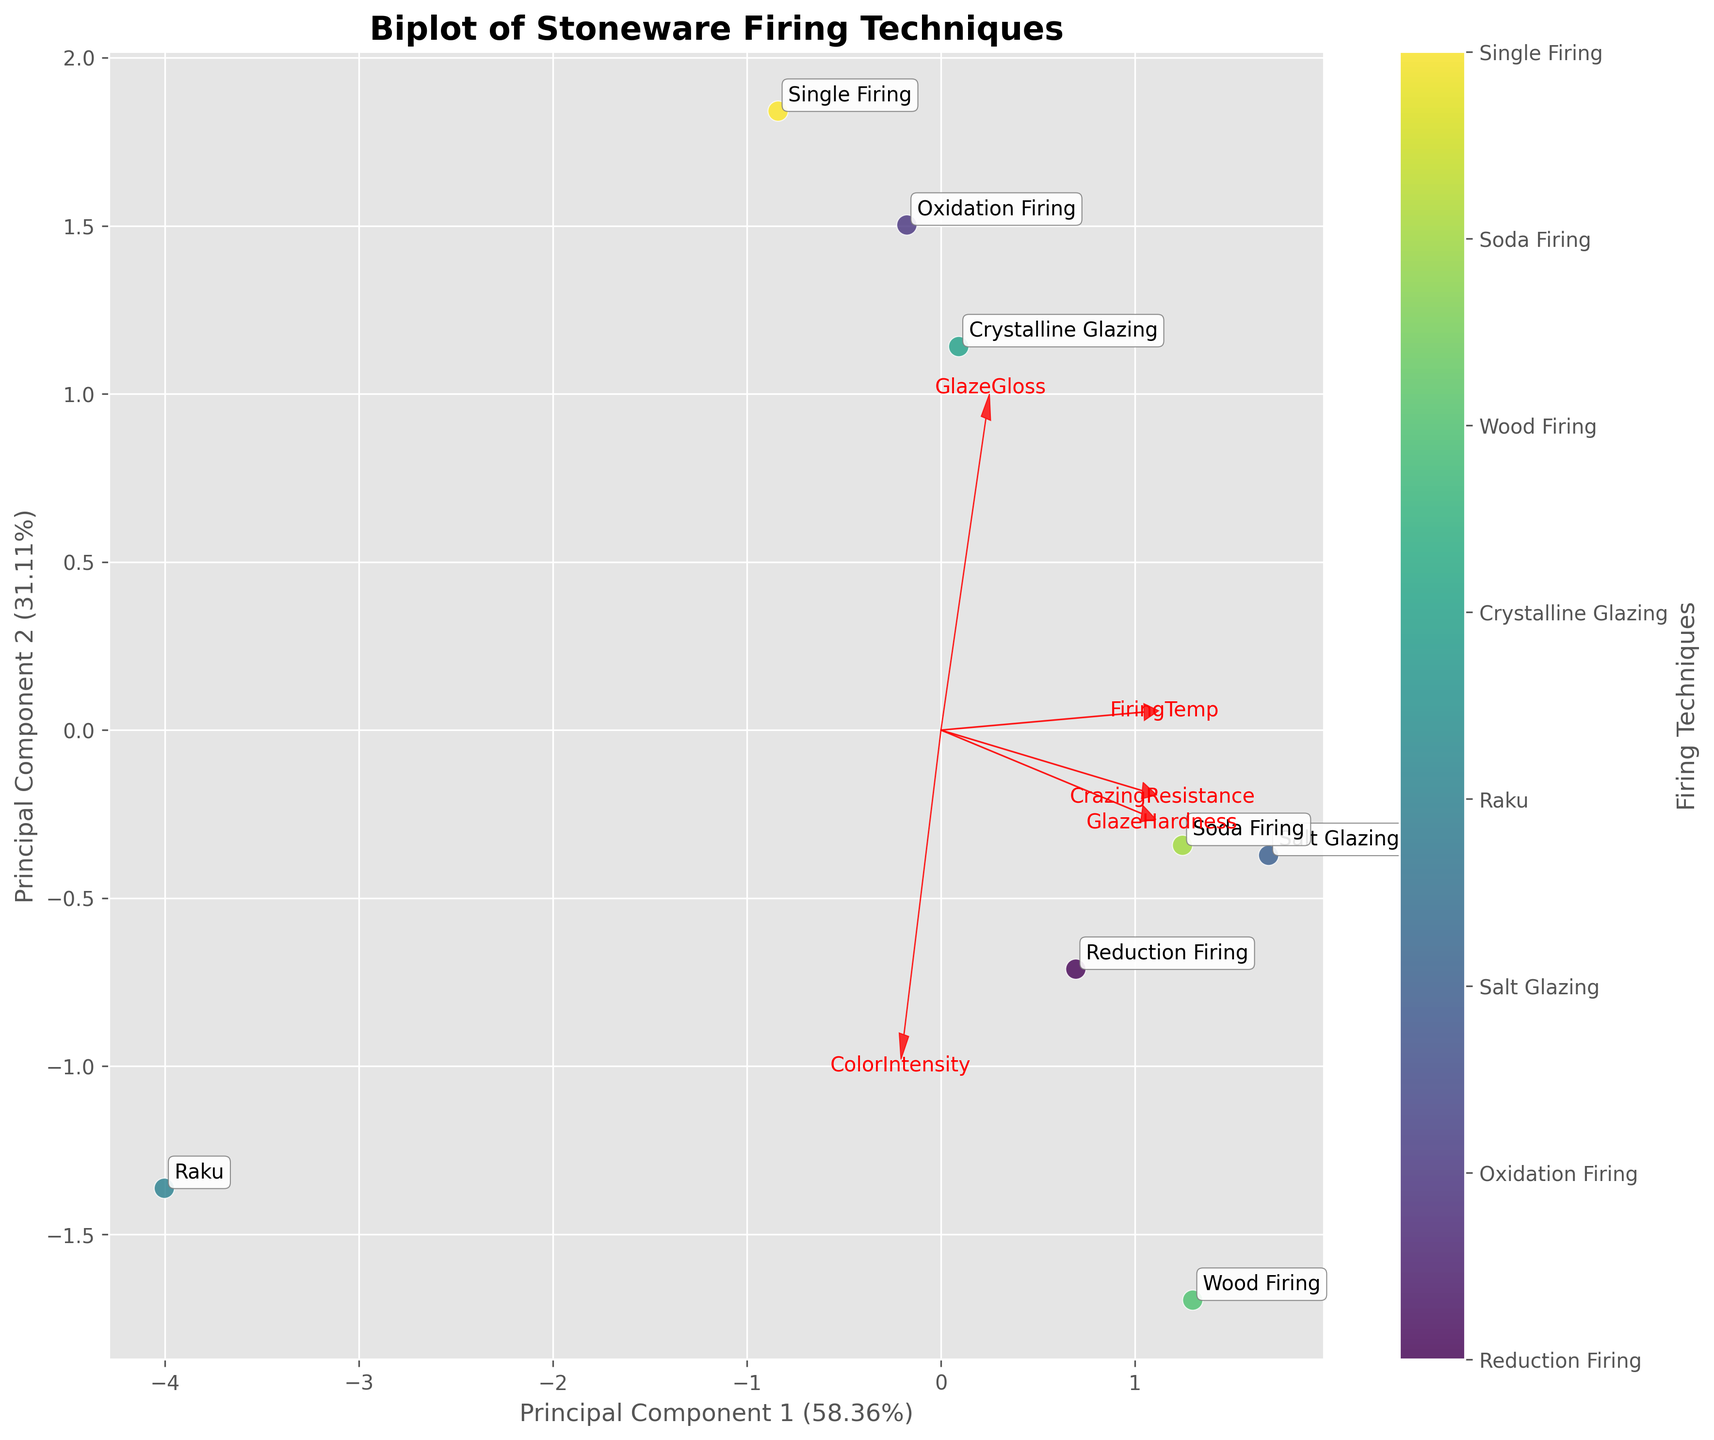How many firing techniques are displayed in the plot? To count the number of firing techniques, check the labels associated with the data points. Each label represents a firing technique.
Answer: 8 What are the two axes labels of the biplot? The axes labels are indicated on the x-axis and y-axis of the biplot figure. They represent the principal components derived from the PCA.
Answer: Principal Component 1 and Principal Component 2 Which firing technique has the highest Glaze Hardness according to the biplot? To determine the firing technique with the highest Glaze Hardness, locate the arrow representing 'Glaze Hardness' and find the data point that aligns closest to this direction.
Answer: Salt Glazing What is the variance explained by the first principal component? Look at the x-axis label, which includes the percentage variance explained by Principal Component 1.
Answer: Around 49.32% Which technique appears closest to the origin of the biplot? Find the data point that is closest to the (0, 0) coordinates of the biplot.
Answer: Single Firing Which techniques are positioned further apart on the biplot? Identify the techniques that have the greatest Euclidean distance between them. This can be seen by identifying data points that are on opposite sides of the plot.
Answer: Raku and Wood Firing How is Glaze Gloss represented in the biplot, and which technique is most closely associated with it? Locate the arrow that represents Glaze Gloss, and find the technique whose data point is in the direction of this arrow.
Answer: Crystalline Glazing What is the relationship between Glaze Gloss and Glaze Hardness in the biplot? Observe the direction and relative positioning of the loadings for Glaze Gloss and Glaze Hardness. If the arrows point in similar directions, they are positively correlated; if they point in opposite directions, they are negatively correlated.
Answer: Slightly Positive Correlation 